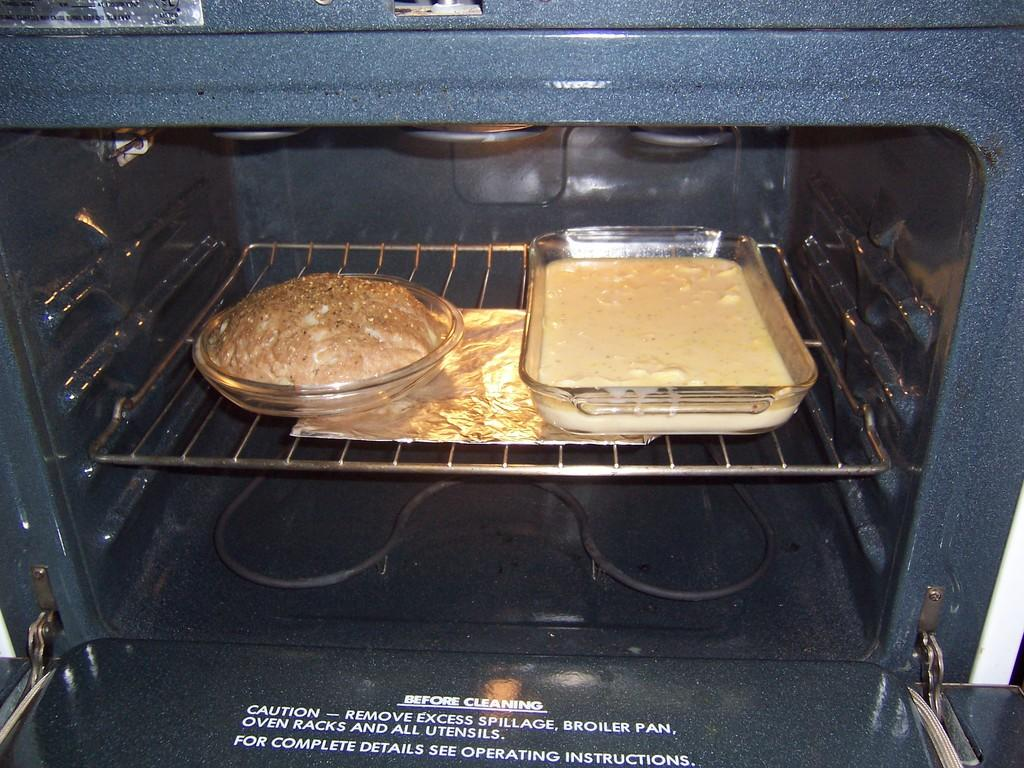<image>
Provide a brief description of the given image. An open oven with instructions on what to do before cleaning 